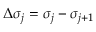Convert formula to latex. <formula><loc_0><loc_0><loc_500><loc_500>\Delta \sigma _ { j } = \sigma _ { j } - \sigma _ { j + 1 }</formula> 